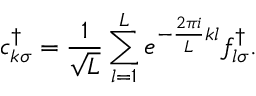Convert formula to latex. <formula><loc_0><loc_0><loc_500><loc_500>c _ { k \sigma } ^ { \dagger } = \frac { 1 } { \sqrt { L } } \sum _ { l = 1 } ^ { L } e ^ { - \frac { 2 \pi i } { L } k l } f _ { l \sigma } ^ { \dagger } .</formula> 